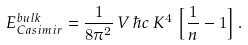<formula> <loc_0><loc_0><loc_500><loc_500>E _ { C a s i m i r } ^ { b u l k } = { \frac { 1 } { 8 \pi ^ { 2 } } } \, V \, \hbar { c } \, K ^ { 4 } \, \left [ { \frac { 1 } { n } } - 1 \right ] .</formula> 